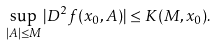Convert formula to latex. <formula><loc_0><loc_0><loc_500><loc_500>\sup _ { | A | \leq M } | D ^ { 2 } f ( x _ { 0 } , A ) | \leq K ( M , x _ { 0 } ) .</formula> 